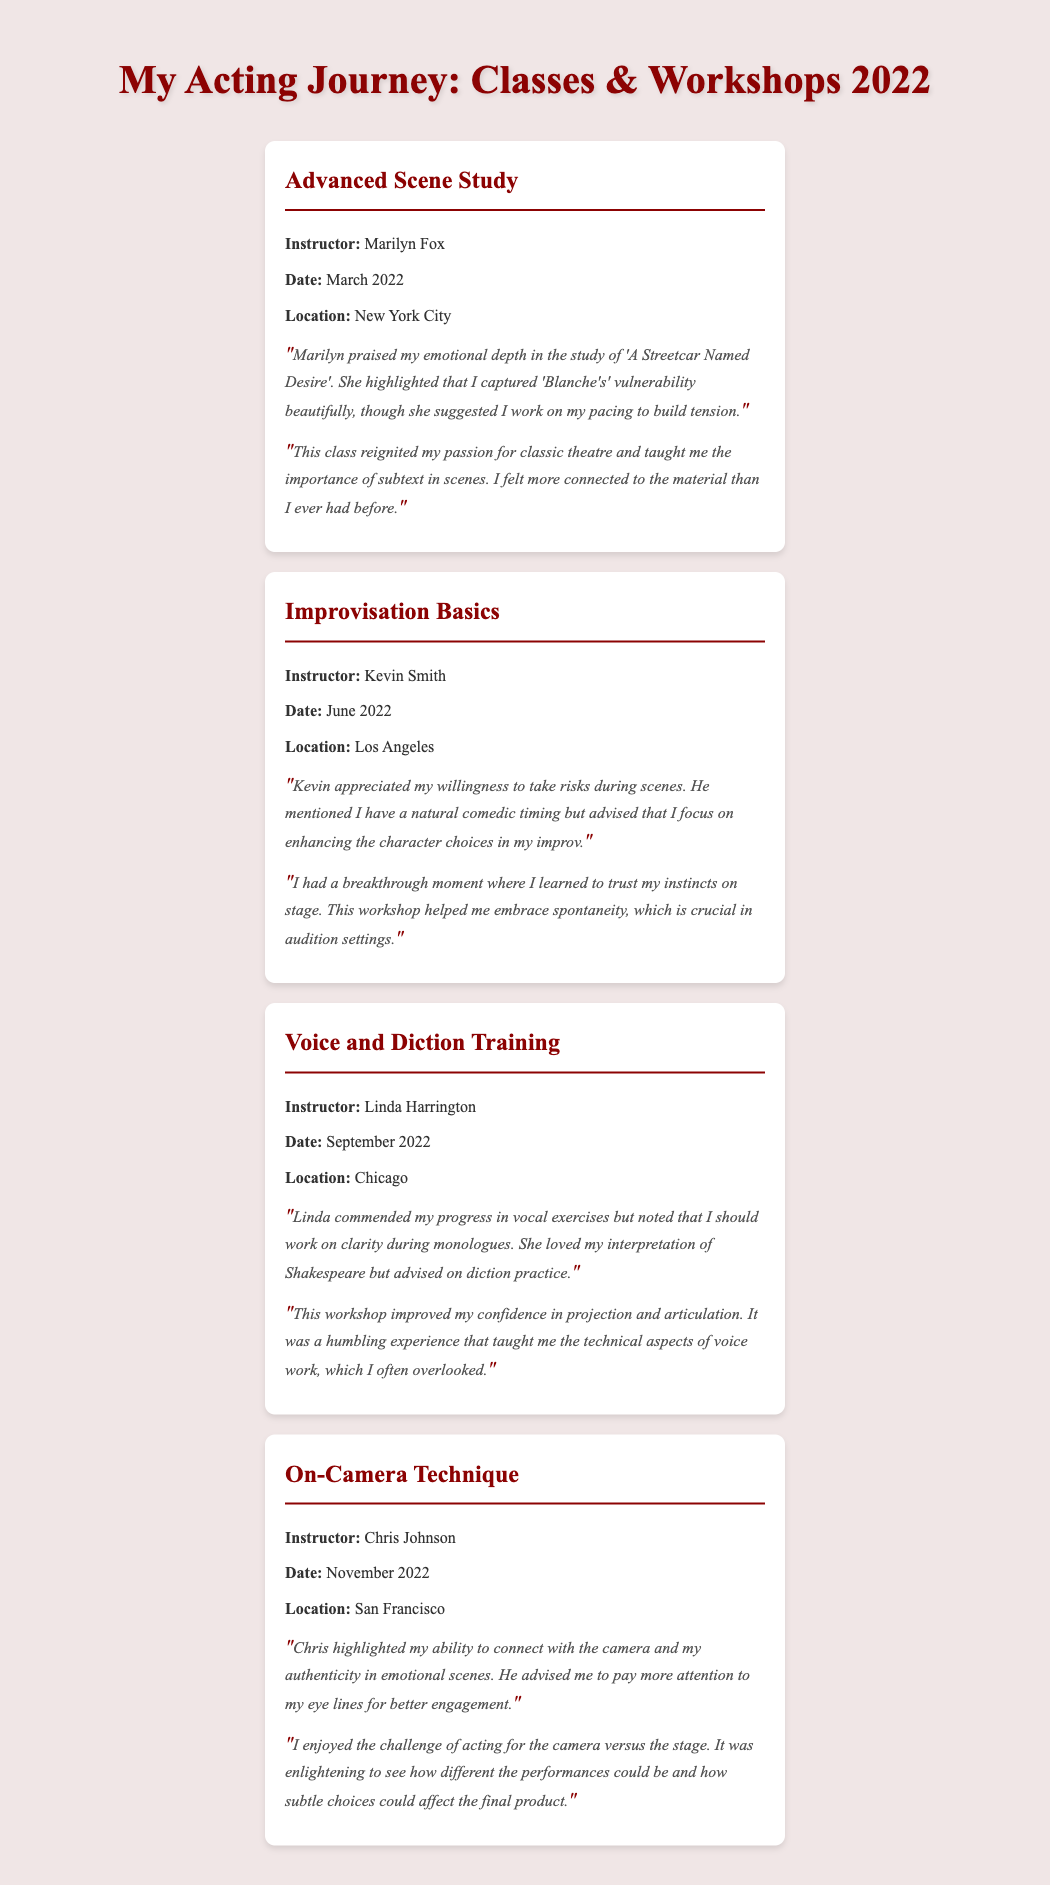what is the title of the first workshop attended? The title of the first workshop is mentioned in the document under its heading.
Answer: Advanced Scene Study who was the instructor for the Voice and Diction Training workshop? The instructor's name is specified in the section related to the Voice and Diction Training workshop.
Answer: Linda Harrington when did the On-Camera Technique workshop take place? The date is provided clearly in the section dedicated to the On-Camera Technique workshop.
Answer: November 2022 which location hosted the Improvisation Basics workshop? The location is noted in the section for the Improvisation Basics workshop.
Answer: Los Angeles what was Marilyn Fox's feedback about the emotional depth shown? The feedback provided includes specific comments from the instructor about the performance in a particular piece.
Answer: Captured 'Blanche's' vulnerability beautifully how did participating in the Voice and Diction Training workshop impact the actress? The personal reflection highlights the outcomes of this workshop, detailing the actress's experiences.
Answer: Improved confidence in projection and articulation what common theme is present in the feedback given by multiple instructors? The feedback often touches on aspects that relate to character portrayal or performance skills, which indicate areas for improvement.
Answer: Work on character choices which acting element did Chris Johnson suggest the actress should focus on for better engagement? The feedback section specifies the elements that Chris Johnson advised should be addressed in performance.
Answer: Eye lines what was a major takeaway from the Improvisation Basics workshop? The reflection reveals key learnings and breakthroughs experienced during this session.
Answer: Trust my instincts on stage 